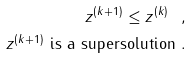<formula> <loc_0><loc_0><loc_500><loc_500>z ^ { ( k + 1 ) } \leq z ^ { ( k ) } \ , \\ z ^ { ( k + 1 ) } \text { is a supersolution} \ .</formula> 